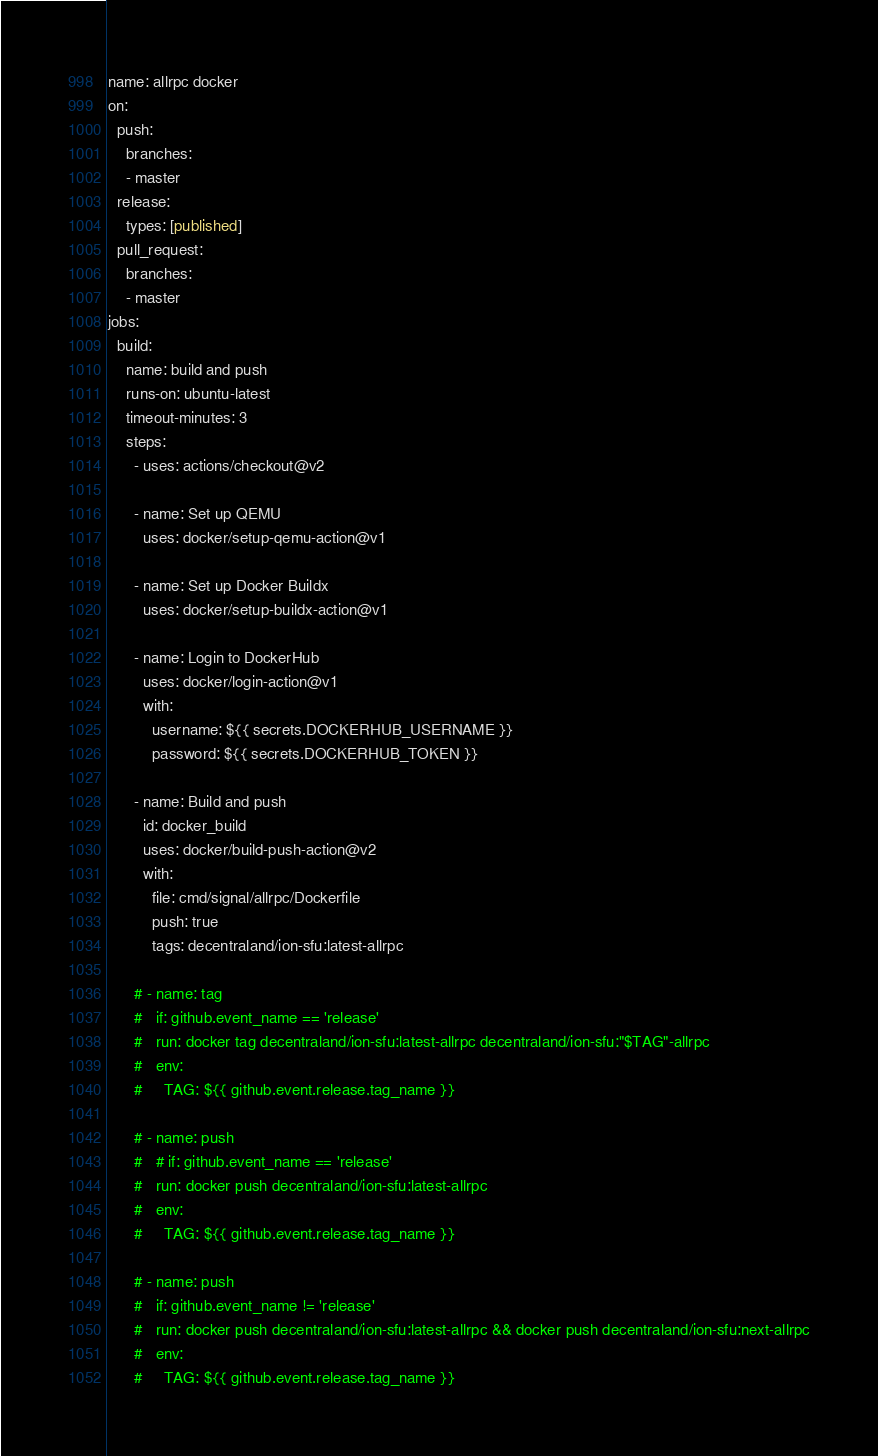<code> <loc_0><loc_0><loc_500><loc_500><_YAML_>name: allrpc docker
on:
  push:
    branches:
    - master
  release:
    types: [published]
  pull_request:
    branches:
    - master
jobs:
  build:
    name: build and push
    runs-on: ubuntu-latest
    timeout-minutes: 3
    steps:
      - uses: actions/checkout@v2

      - name: Set up QEMU
        uses: docker/setup-qemu-action@v1

      - name: Set up Docker Buildx
        uses: docker/setup-buildx-action@v1

      - name: Login to DockerHub
        uses: docker/login-action@v1
        with:
          username: ${{ secrets.DOCKERHUB_USERNAME }}
          password: ${{ secrets.DOCKERHUB_TOKEN }}

      - name: Build and push
        id: docker_build
        uses: docker/build-push-action@v2
        with:
          file: cmd/signal/allrpc/Dockerfile
          push: true
          tags: decentraland/ion-sfu:latest-allrpc

      # - name: tag
      #   if: github.event_name == 'release'
      #   run: docker tag decentraland/ion-sfu:latest-allrpc decentraland/ion-sfu:"$TAG"-allrpc
      #   env:
      #     TAG: ${{ github.event.release.tag_name }}

      # - name: push
      #   # if: github.event_name == 'release'
      #   run: docker push decentraland/ion-sfu:latest-allrpc
      #   env:
      #     TAG: ${{ github.event.release.tag_name }}

      # - name: push
      #   if: github.event_name != 'release'
      #   run: docker push decentraland/ion-sfu:latest-allrpc && docker push decentraland/ion-sfu:next-allrpc
      #   env:
      #     TAG: ${{ github.event.release.tag_name }}</code> 